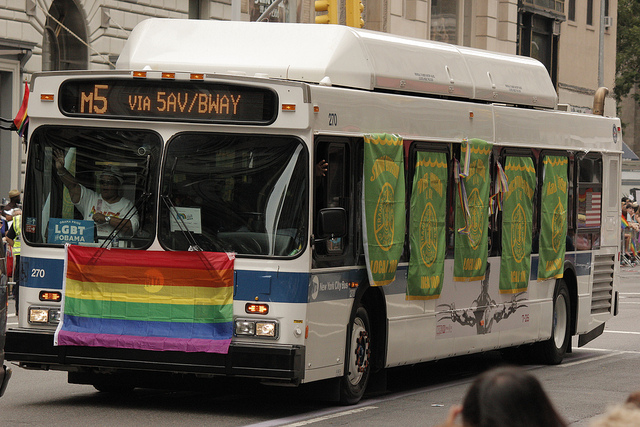Read all the text in this image. LGBT 270 M 5 VIA OBAMA 5AV/BWA 